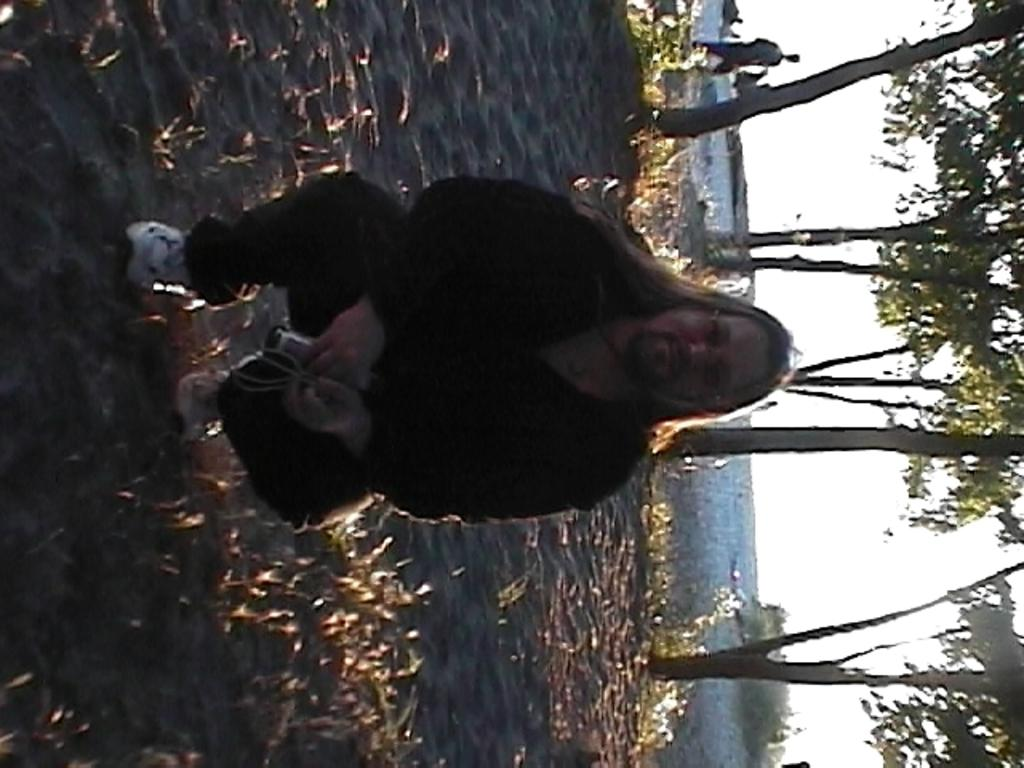Who is the main subject in the front of the image? There is a man in the front of the image. What can be seen in the background of the image? There are trees, plants, and water visible in the background of the image. What part of the sky is visible in the image? The sky is visible on the right side of the image. What type of pie is being served at the organization's event in the image? There is no pie or organization present in the image; it features a man in the foreground and natural elements in the background. 